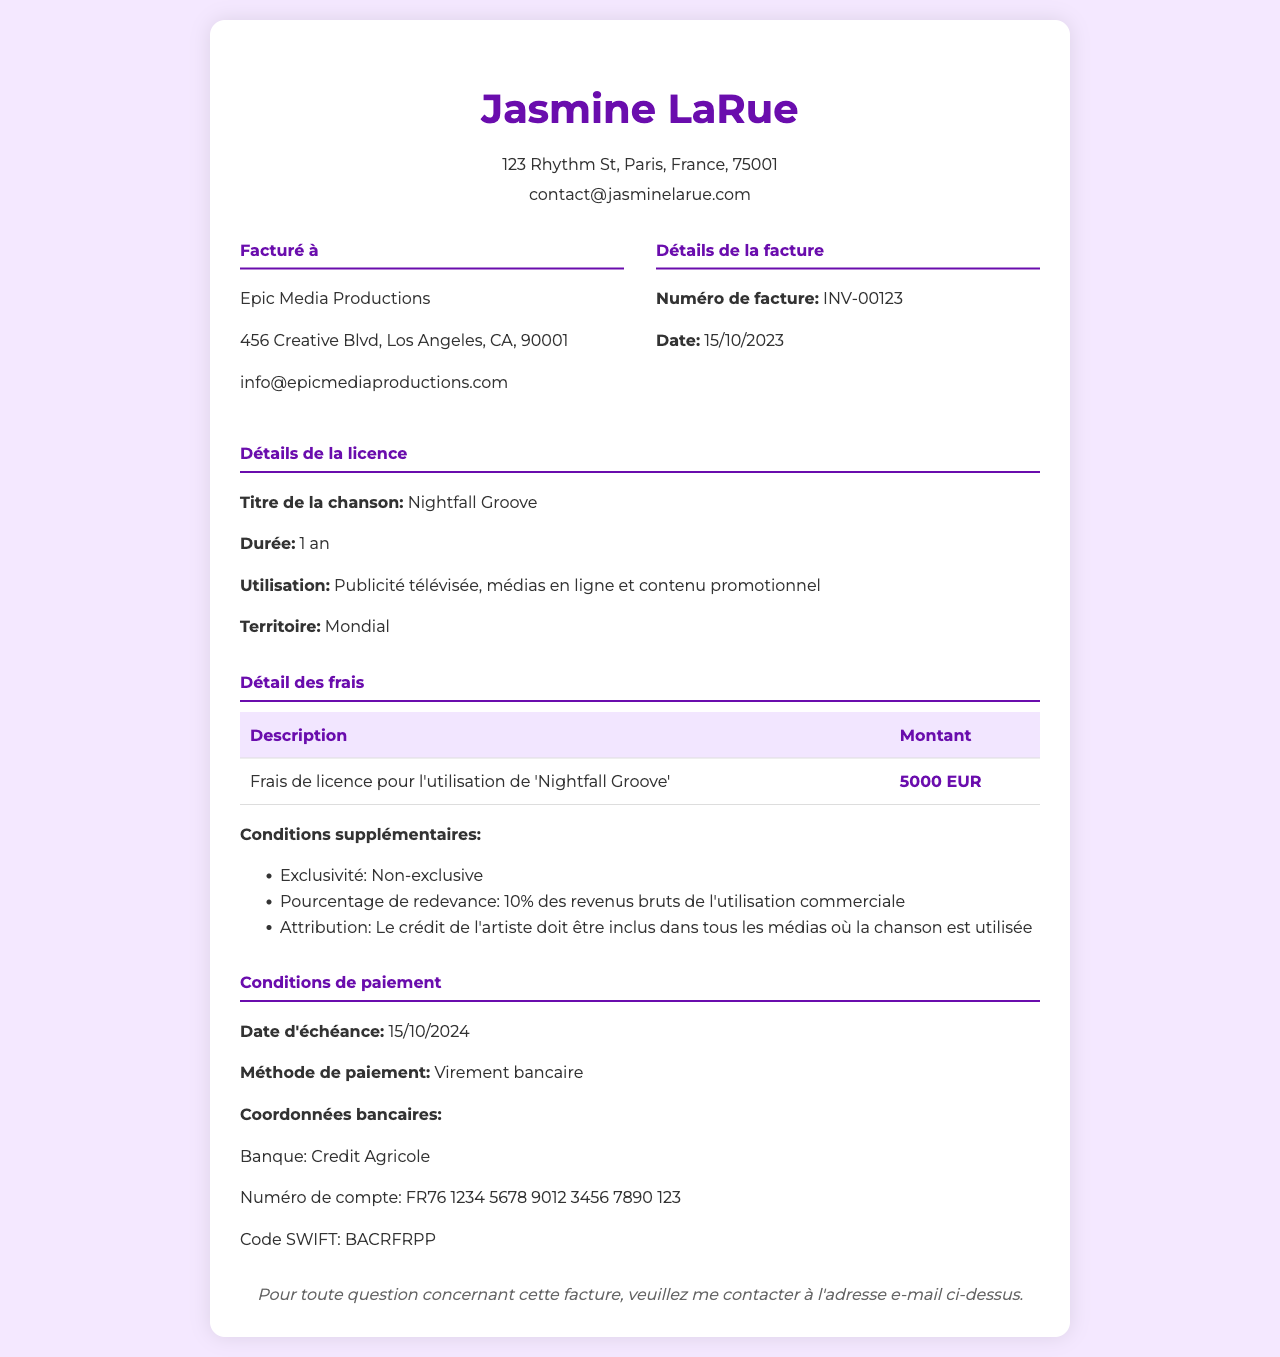what is the title of the song? The title of the song is specifically mentioned in the licensing details section of the document.
Answer: Nightfall Groove what is the invoice number? The invoice number can be found in the invoice details section, under Détails de la facture.
Answer: INV-00123 what is the licensing fee amount? The licensing fee amount is detailed in the fee breakdown section with a specific monetary value.
Answer: 5000 EUR what is the territory for the song usage? The territory is outlined in the licensing details section, indicating where the song can be used.
Answer: Mondial how long is the duration of the license? The duration of the license is stated clearly in the licensing details and specifies the time period for use.
Answer: 1 an what is the additional percentage for royalties? The additional percentage for royalties is found in the fee breakdown section, specifying the artist's entitlement after commercial use.
Answer: 10% when is the payment due date? The payment due date is indicated in the payment terms section of the document.
Answer: 15/10/2024 what is the method of payment? The method of payment is specified in the payment terms section, detailing how the payment should be made.
Answer: Virement bancaire who is the client billed on this invoice? The client's details are provided in the client information section, indicating who is responsible for the payment.
Answer: Epic Media Productions 